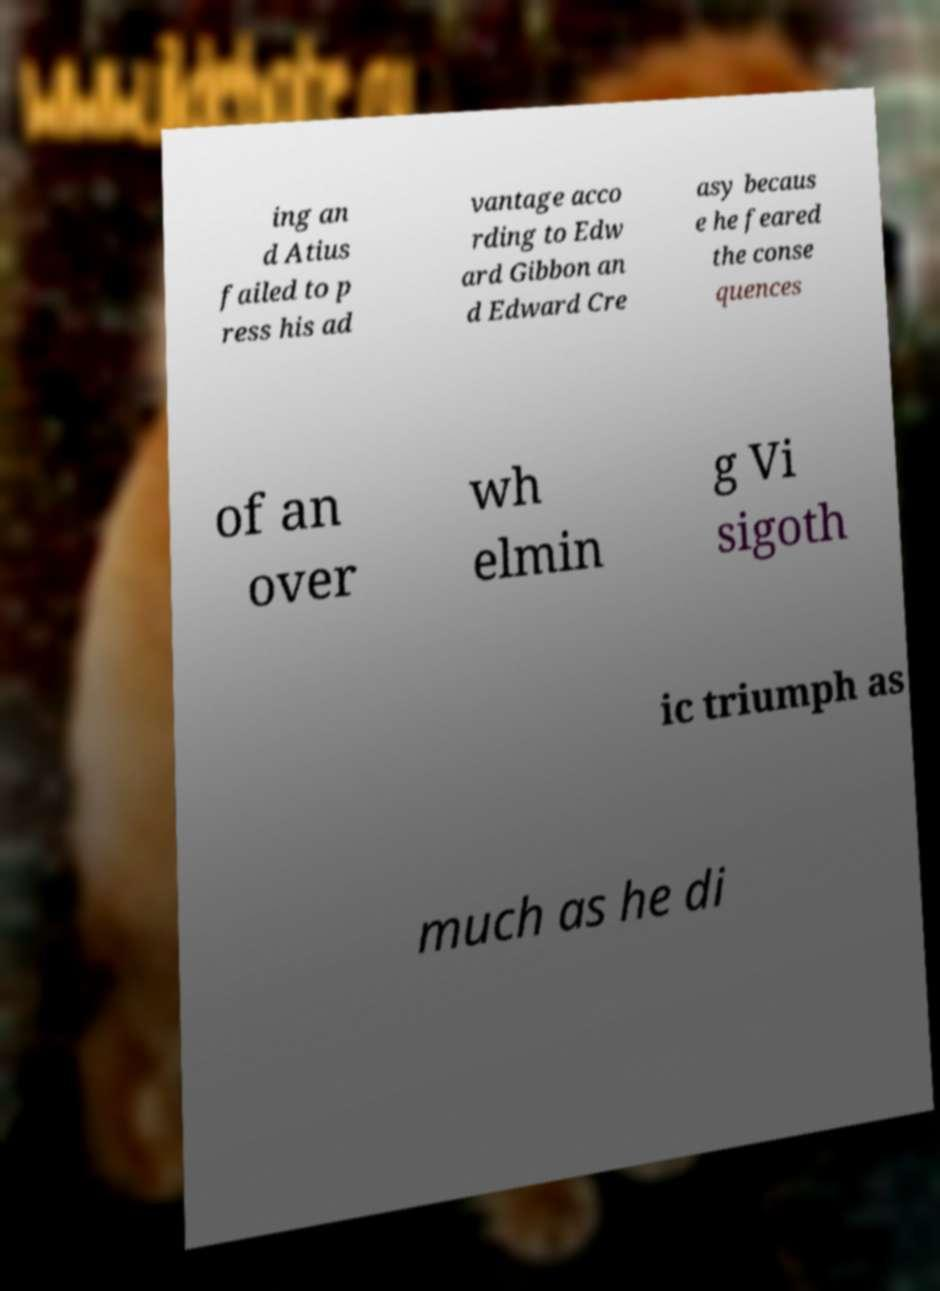Could you extract and type out the text from this image? ing an d Atius failed to p ress his ad vantage acco rding to Edw ard Gibbon an d Edward Cre asy becaus e he feared the conse quences of an over wh elmin g Vi sigoth ic triumph as much as he di 